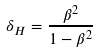Convert formula to latex. <formula><loc_0><loc_0><loc_500><loc_500>\delta _ { H } = \frac { \beta ^ { 2 } } { 1 - \beta ^ { 2 } }</formula> 